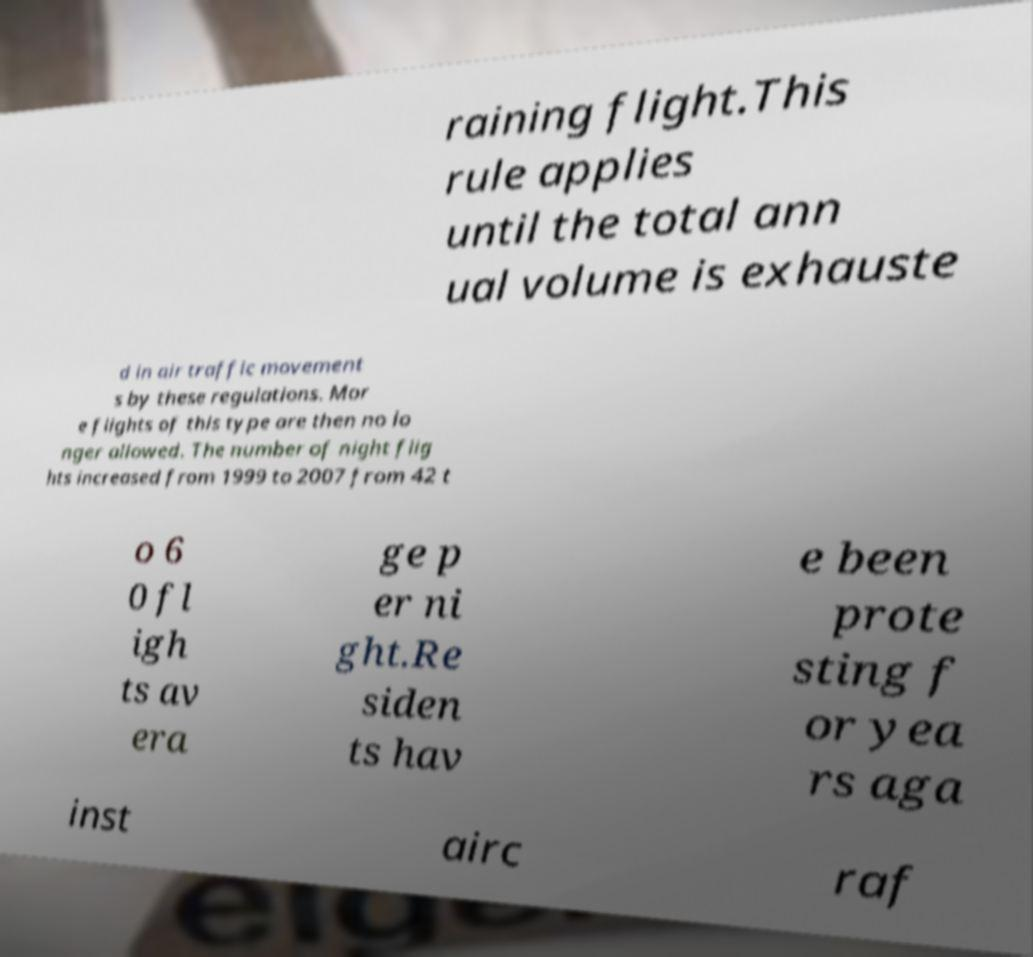I need the written content from this picture converted into text. Can you do that? raining flight.This rule applies until the total ann ual volume is exhauste d in air traffic movement s by these regulations. Mor e flights of this type are then no lo nger allowed. The number of night flig hts increased from 1999 to 2007 from 42 t o 6 0 fl igh ts av era ge p er ni ght.Re siden ts hav e been prote sting f or yea rs aga inst airc raf 